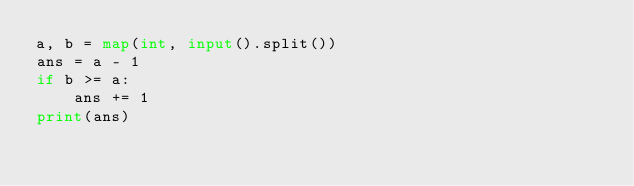Convert code to text. <code><loc_0><loc_0><loc_500><loc_500><_Python_>a, b = map(int, input().split())
ans = a - 1
if b >= a:
    ans += 1
print(ans)</code> 